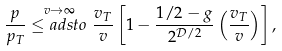Convert formula to latex. <formula><loc_0><loc_0><loc_500><loc_500>\frac { p } { p _ { T } } \stackrel { v \to \infty } { \leq a d s t o } \frac { v _ { T } } { v } \left [ 1 - \frac { 1 / 2 - g } { 2 ^ { \mathcal { D } / 2 } } \left ( \frac { v _ { T } } { v } \right ) \right ] ,</formula> 